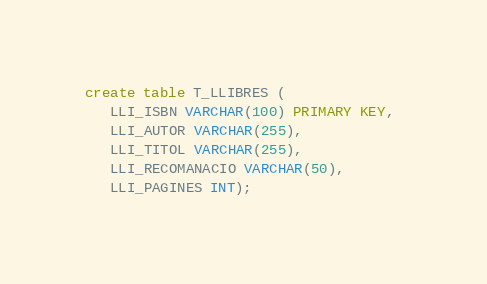<code> <loc_0><loc_0><loc_500><loc_500><_SQL_>create table T_LLIBRES (
   LLI_ISBN VARCHAR(100) PRIMARY KEY, 
   LLI_AUTOR VARCHAR(255),
   LLI_TITOL VARCHAR(255),
   LLI_RECOMANACIO VARCHAR(50),
   LLI_PAGINES INT);</code> 